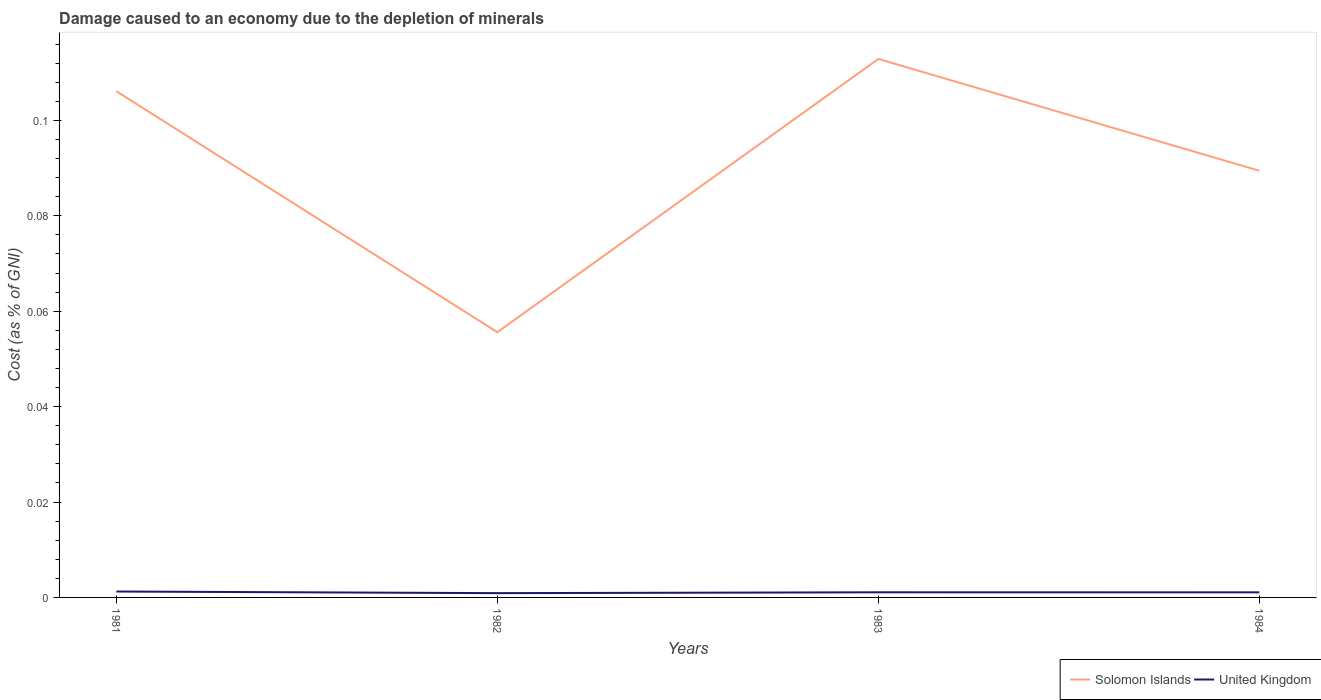Is the number of lines equal to the number of legend labels?
Ensure brevity in your answer.  Yes. Across all years, what is the maximum cost of damage caused due to the depletion of minerals in United Kingdom?
Make the answer very short. 0. What is the total cost of damage caused due to the depletion of minerals in Solomon Islands in the graph?
Keep it short and to the point. -0.03. What is the difference between the highest and the second highest cost of damage caused due to the depletion of minerals in Solomon Islands?
Your response must be concise. 0.06. What is the difference between the highest and the lowest cost of damage caused due to the depletion of minerals in United Kingdom?
Make the answer very short. 2. How many lines are there?
Offer a terse response. 2. What is the difference between two consecutive major ticks on the Y-axis?
Offer a very short reply. 0.02. How many legend labels are there?
Your answer should be compact. 2. How are the legend labels stacked?
Keep it short and to the point. Horizontal. What is the title of the graph?
Your answer should be compact. Damage caused to an economy due to the depletion of minerals. What is the label or title of the X-axis?
Offer a terse response. Years. What is the label or title of the Y-axis?
Ensure brevity in your answer.  Cost (as % of GNI). What is the Cost (as % of GNI) in Solomon Islands in 1981?
Your answer should be very brief. 0.11. What is the Cost (as % of GNI) in United Kingdom in 1981?
Provide a short and direct response. 0. What is the Cost (as % of GNI) of Solomon Islands in 1982?
Give a very brief answer. 0.06. What is the Cost (as % of GNI) of United Kingdom in 1982?
Provide a short and direct response. 0. What is the Cost (as % of GNI) in Solomon Islands in 1983?
Keep it short and to the point. 0.11. What is the Cost (as % of GNI) of United Kingdom in 1983?
Offer a very short reply. 0. What is the Cost (as % of GNI) of Solomon Islands in 1984?
Offer a very short reply. 0.09. What is the Cost (as % of GNI) in United Kingdom in 1984?
Provide a short and direct response. 0. Across all years, what is the maximum Cost (as % of GNI) of Solomon Islands?
Provide a short and direct response. 0.11. Across all years, what is the maximum Cost (as % of GNI) of United Kingdom?
Your answer should be compact. 0. Across all years, what is the minimum Cost (as % of GNI) in Solomon Islands?
Offer a terse response. 0.06. Across all years, what is the minimum Cost (as % of GNI) in United Kingdom?
Offer a terse response. 0. What is the total Cost (as % of GNI) of Solomon Islands in the graph?
Make the answer very short. 0.36. What is the total Cost (as % of GNI) in United Kingdom in the graph?
Your answer should be compact. 0. What is the difference between the Cost (as % of GNI) of Solomon Islands in 1981 and that in 1982?
Your answer should be compact. 0.05. What is the difference between the Cost (as % of GNI) of United Kingdom in 1981 and that in 1982?
Give a very brief answer. 0. What is the difference between the Cost (as % of GNI) of Solomon Islands in 1981 and that in 1983?
Your answer should be very brief. -0.01. What is the difference between the Cost (as % of GNI) of United Kingdom in 1981 and that in 1983?
Provide a short and direct response. 0. What is the difference between the Cost (as % of GNI) of Solomon Islands in 1981 and that in 1984?
Offer a very short reply. 0.02. What is the difference between the Cost (as % of GNI) in Solomon Islands in 1982 and that in 1983?
Ensure brevity in your answer.  -0.06. What is the difference between the Cost (as % of GNI) of United Kingdom in 1982 and that in 1983?
Your response must be concise. -0. What is the difference between the Cost (as % of GNI) of Solomon Islands in 1982 and that in 1984?
Provide a short and direct response. -0.03. What is the difference between the Cost (as % of GNI) of United Kingdom in 1982 and that in 1984?
Offer a very short reply. -0. What is the difference between the Cost (as % of GNI) in Solomon Islands in 1983 and that in 1984?
Your answer should be very brief. 0.02. What is the difference between the Cost (as % of GNI) of Solomon Islands in 1981 and the Cost (as % of GNI) of United Kingdom in 1982?
Ensure brevity in your answer.  0.11. What is the difference between the Cost (as % of GNI) in Solomon Islands in 1981 and the Cost (as % of GNI) in United Kingdom in 1983?
Make the answer very short. 0.1. What is the difference between the Cost (as % of GNI) of Solomon Islands in 1981 and the Cost (as % of GNI) of United Kingdom in 1984?
Offer a terse response. 0.11. What is the difference between the Cost (as % of GNI) in Solomon Islands in 1982 and the Cost (as % of GNI) in United Kingdom in 1983?
Your answer should be very brief. 0.05. What is the difference between the Cost (as % of GNI) in Solomon Islands in 1982 and the Cost (as % of GNI) in United Kingdom in 1984?
Provide a short and direct response. 0.05. What is the difference between the Cost (as % of GNI) in Solomon Islands in 1983 and the Cost (as % of GNI) in United Kingdom in 1984?
Your answer should be very brief. 0.11. What is the average Cost (as % of GNI) in Solomon Islands per year?
Give a very brief answer. 0.09. What is the average Cost (as % of GNI) of United Kingdom per year?
Ensure brevity in your answer.  0. In the year 1981, what is the difference between the Cost (as % of GNI) of Solomon Islands and Cost (as % of GNI) of United Kingdom?
Your answer should be very brief. 0.1. In the year 1982, what is the difference between the Cost (as % of GNI) of Solomon Islands and Cost (as % of GNI) of United Kingdom?
Offer a terse response. 0.05. In the year 1983, what is the difference between the Cost (as % of GNI) of Solomon Islands and Cost (as % of GNI) of United Kingdom?
Your response must be concise. 0.11. In the year 1984, what is the difference between the Cost (as % of GNI) in Solomon Islands and Cost (as % of GNI) in United Kingdom?
Offer a very short reply. 0.09. What is the ratio of the Cost (as % of GNI) in Solomon Islands in 1981 to that in 1982?
Ensure brevity in your answer.  1.91. What is the ratio of the Cost (as % of GNI) in United Kingdom in 1981 to that in 1982?
Your response must be concise. 1.38. What is the ratio of the Cost (as % of GNI) in Solomon Islands in 1981 to that in 1983?
Offer a terse response. 0.94. What is the ratio of the Cost (as % of GNI) of United Kingdom in 1981 to that in 1983?
Give a very brief answer. 1.15. What is the ratio of the Cost (as % of GNI) of Solomon Islands in 1981 to that in 1984?
Your answer should be compact. 1.19. What is the ratio of the Cost (as % of GNI) in United Kingdom in 1981 to that in 1984?
Offer a very short reply. 1.16. What is the ratio of the Cost (as % of GNI) of Solomon Islands in 1982 to that in 1983?
Provide a short and direct response. 0.49. What is the ratio of the Cost (as % of GNI) of United Kingdom in 1982 to that in 1983?
Provide a succinct answer. 0.83. What is the ratio of the Cost (as % of GNI) in Solomon Islands in 1982 to that in 1984?
Provide a short and direct response. 0.62. What is the ratio of the Cost (as % of GNI) in United Kingdom in 1982 to that in 1984?
Give a very brief answer. 0.84. What is the ratio of the Cost (as % of GNI) in Solomon Islands in 1983 to that in 1984?
Your response must be concise. 1.26. What is the ratio of the Cost (as % of GNI) in United Kingdom in 1983 to that in 1984?
Ensure brevity in your answer.  1.01. What is the difference between the highest and the second highest Cost (as % of GNI) in Solomon Islands?
Make the answer very short. 0.01. What is the difference between the highest and the lowest Cost (as % of GNI) in Solomon Islands?
Ensure brevity in your answer.  0.06. 